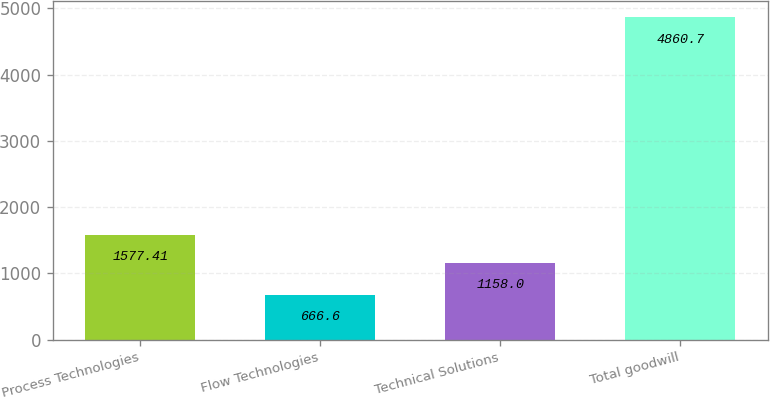Convert chart. <chart><loc_0><loc_0><loc_500><loc_500><bar_chart><fcel>Process Technologies<fcel>Flow Technologies<fcel>Technical Solutions<fcel>Total goodwill<nl><fcel>1577.41<fcel>666.6<fcel>1158<fcel>4860.7<nl></chart> 